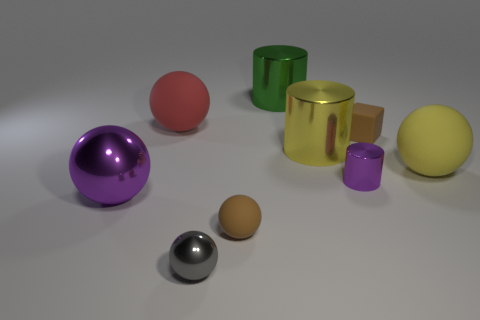Subtract all tiny shiny cylinders. How many cylinders are left? 2 Subtract 3 balls. How many balls are left? 2 Subtract all gray spheres. How many spheres are left? 4 Add 8 large yellow shiny cylinders. How many large yellow shiny cylinders exist? 9 Subtract 0 cyan cubes. How many objects are left? 9 Subtract all cubes. How many objects are left? 8 Subtract all blue balls. Subtract all green cubes. How many balls are left? 5 Subtract all green balls. How many yellow cylinders are left? 1 Subtract all matte spheres. Subtract all brown matte things. How many objects are left? 4 Add 7 purple metal balls. How many purple metal balls are left? 8 